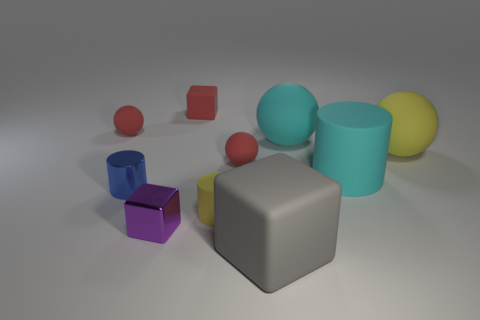What is the material of the purple object that is the same shape as the large gray object?
Give a very brief answer. Metal. What size is the yellow matte cylinder?
Your response must be concise. Small. How many other things are the same color as the large matte cylinder?
Make the answer very short. 1. What is the color of the thing that is both in front of the metal cylinder and behind the purple metal thing?
Your response must be concise. Yellow. What number of large cylinders are there?
Give a very brief answer. 1. Do the small blue thing and the purple object have the same material?
Your answer should be very brief. Yes. There is a red matte object left of the red rubber object that is behind the small red matte object left of the metal cylinder; what shape is it?
Keep it short and to the point. Sphere. Are the large cyan ball behind the small purple metal object and the cylinder to the left of the tiny yellow matte cylinder made of the same material?
Keep it short and to the point. No. What is the material of the blue object?
Your response must be concise. Metal. How many other matte things have the same shape as the big yellow thing?
Your answer should be compact. 3. 